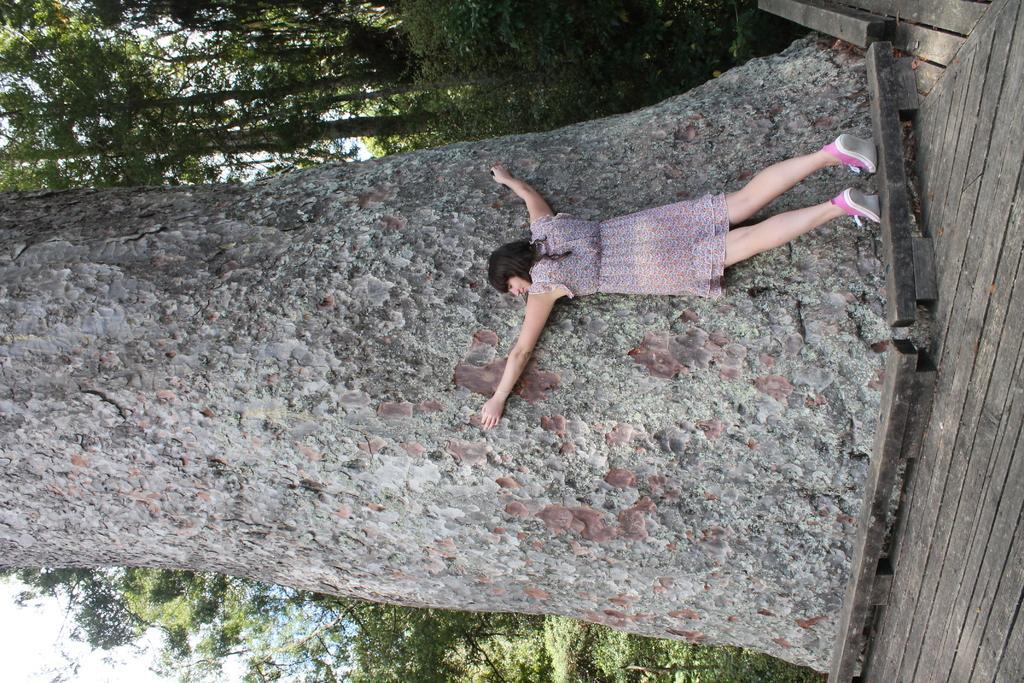How would you summarize this image in a sentence or two? In this picture there is a lady in the image, she is hugging a big tree trunk and there are trees in the background area of the image. 